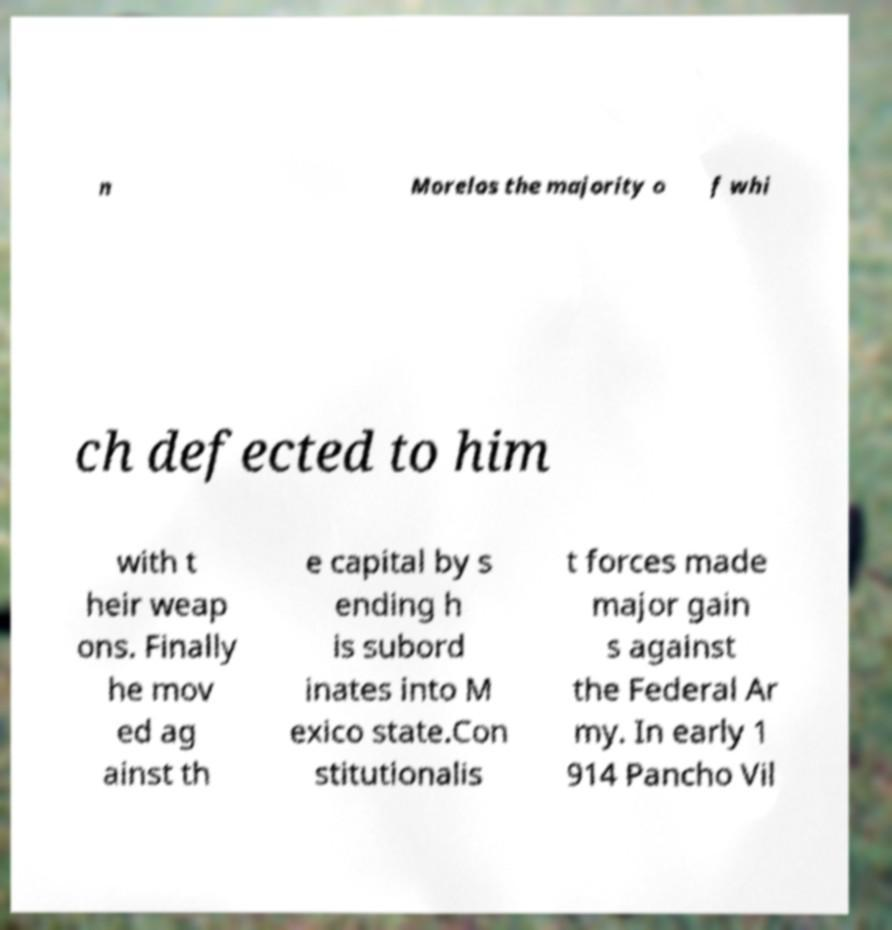Can you accurately transcribe the text from the provided image for me? n Morelos the majority o f whi ch defected to him with t heir weap ons. Finally he mov ed ag ainst th e capital by s ending h is subord inates into M exico state.Con stitutionalis t forces made major gain s against the Federal Ar my. In early 1 914 Pancho Vil 